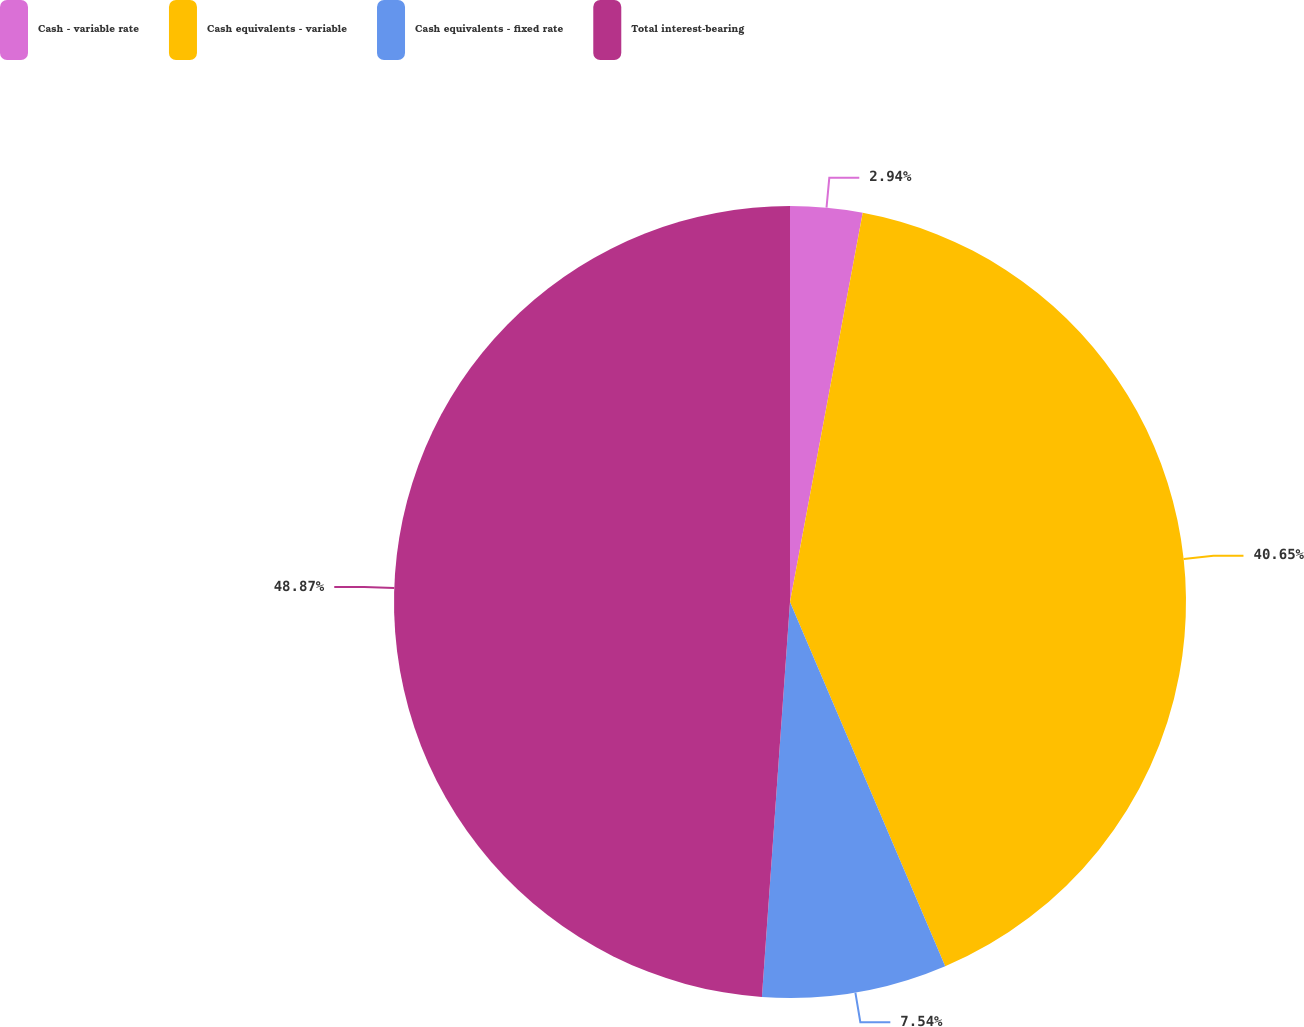Convert chart. <chart><loc_0><loc_0><loc_500><loc_500><pie_chart><fcel>Cash - variable rate<fcel>Cash equivalents - variable<fcel>Cash equivalents - fixed rate<fcel>Total interest-bearing<nl><fcel>2.94%<fcel>40.65%<fcel>7.54%<fcel>48.87%<nl></chart> 